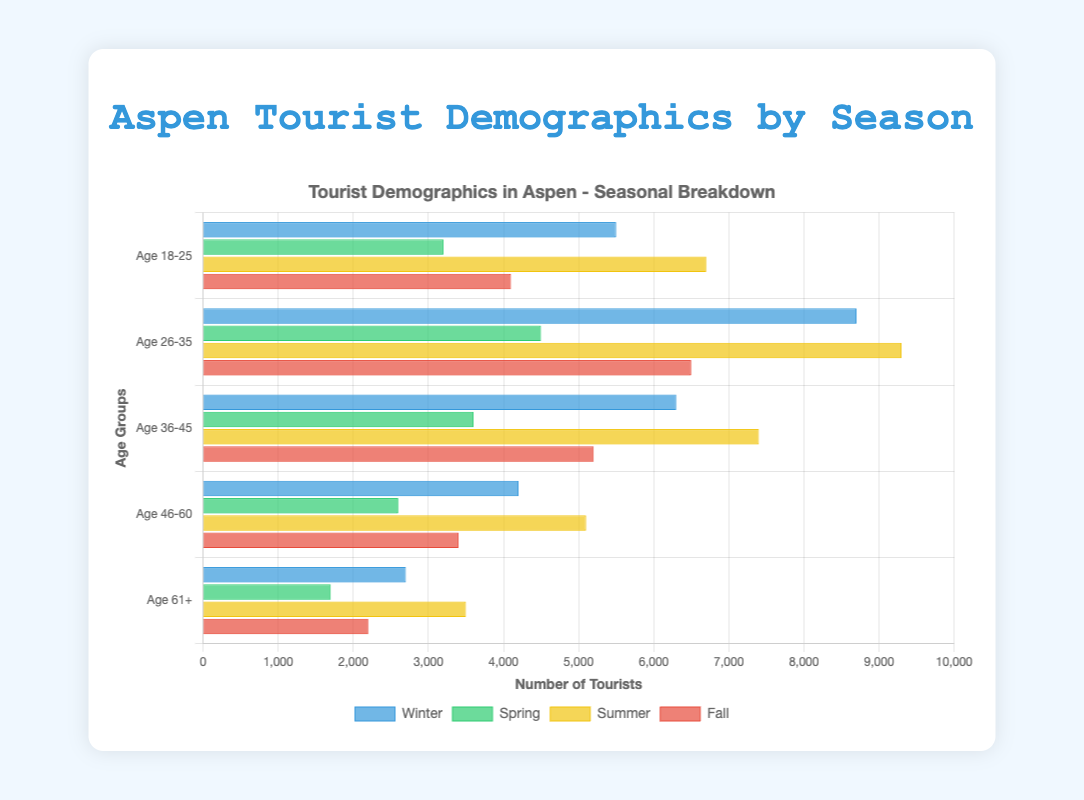What's the most popular age group in Winter? By observing the chart, the bar representing "Age 26-35" in Winter is the tallest compared to other age groups in Winter.
Answer: Age 26-35 Which season sees the highest number of tourists in the "Age 61+" category? By comparing the "Age 61+" category bars across all seasons, the Summer bar is the longest, indicating the highest number of tourists in that age group.
Answer: Summer In which season is the number of tourists aged 18-25 the lowest? The shortest bar for the "Age 18-25" category across the seasons is in Spring.
Answer: Spring Compare the number of tourists aged 36-45 in Winter and Summer and identify which season has more. The bar for "Age 36-45" in Summer is longer than in Winter, indicating more tourists of this age group in Summer.
Answer: Summer What is the total number of tourists aged 46-60 across all seasons? Adding up the tourists in the "Age 46-60" category: Winter (4200) + Spring (2600) + Summer (5100) + Fall (3400) gives 15300.
Answer: 15300 Which season attracts more tourists overall, Winter or Fall? Sum of tourists in each category within Winter (5500+8700+6300+4200+2700 = 27400) is compared to Fall (4100+6500+5200+3400+2200 = 21400), Winter is higher.
Answer: Winter For the age group "Age 36-45", what is the average number of tourists per season? Summing the numbers for "Age 36-45": (6300 + 3600 + 7400 + 5200 = 22500), divide by 4 gives an average of 5625 tourists.
Answer: 5625 How many more tourists are there aged 26-35 in Summer compared to Spring? Subtracting the number of tourists aged 26-35 in Spring (4500) from those in Summer (9300) gives a difference of 4800.
Answer: 4800 What is the difference in the number of tourists aged 18-25 between Fall and Winter? Subtracting the number of tourists in Fall (4100) from Winter (5500) gives a difference of 1400.
Answer: 1400 Considering the "Age 61+" category, which season shows the second highest number of tourists? Comparing the bars for "Age 61+" category, the tallest one is for Summer and the second tallest is for Winter.
Answer: Winter 